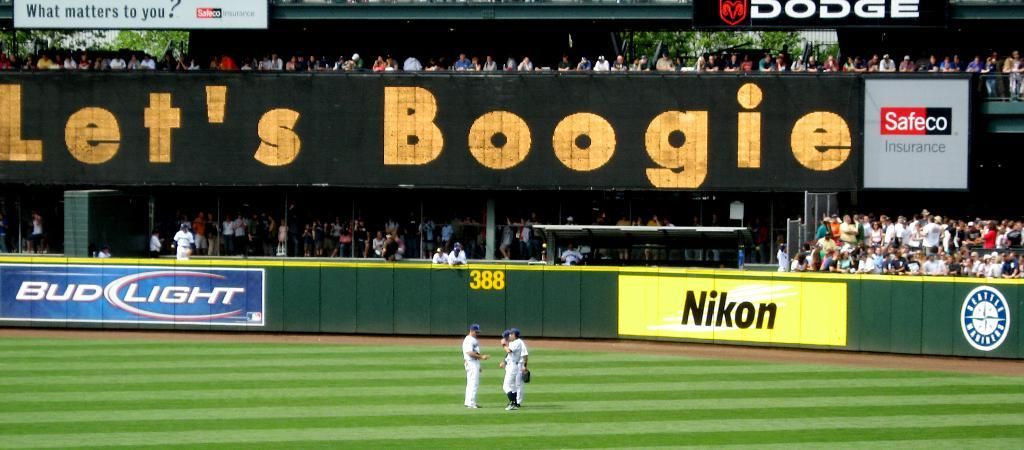<image>
Offer a succinct explanation of the picture presented. Baseball players gather in an outfield below an outfield banner sponsored by Nikon. 